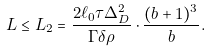Convert formula to latex. <formula><loc_0><loc_0><loc_500><loc_500>L \leq L _ { 2 } = \frac { 2 \ell _ { 0 } \tau \Delta ^ { 2 } _ { D } } { \Gamma \delta \rho } \cdot \frac { ( b + 1 ) ^ { 3 } } { b } .</formula> 